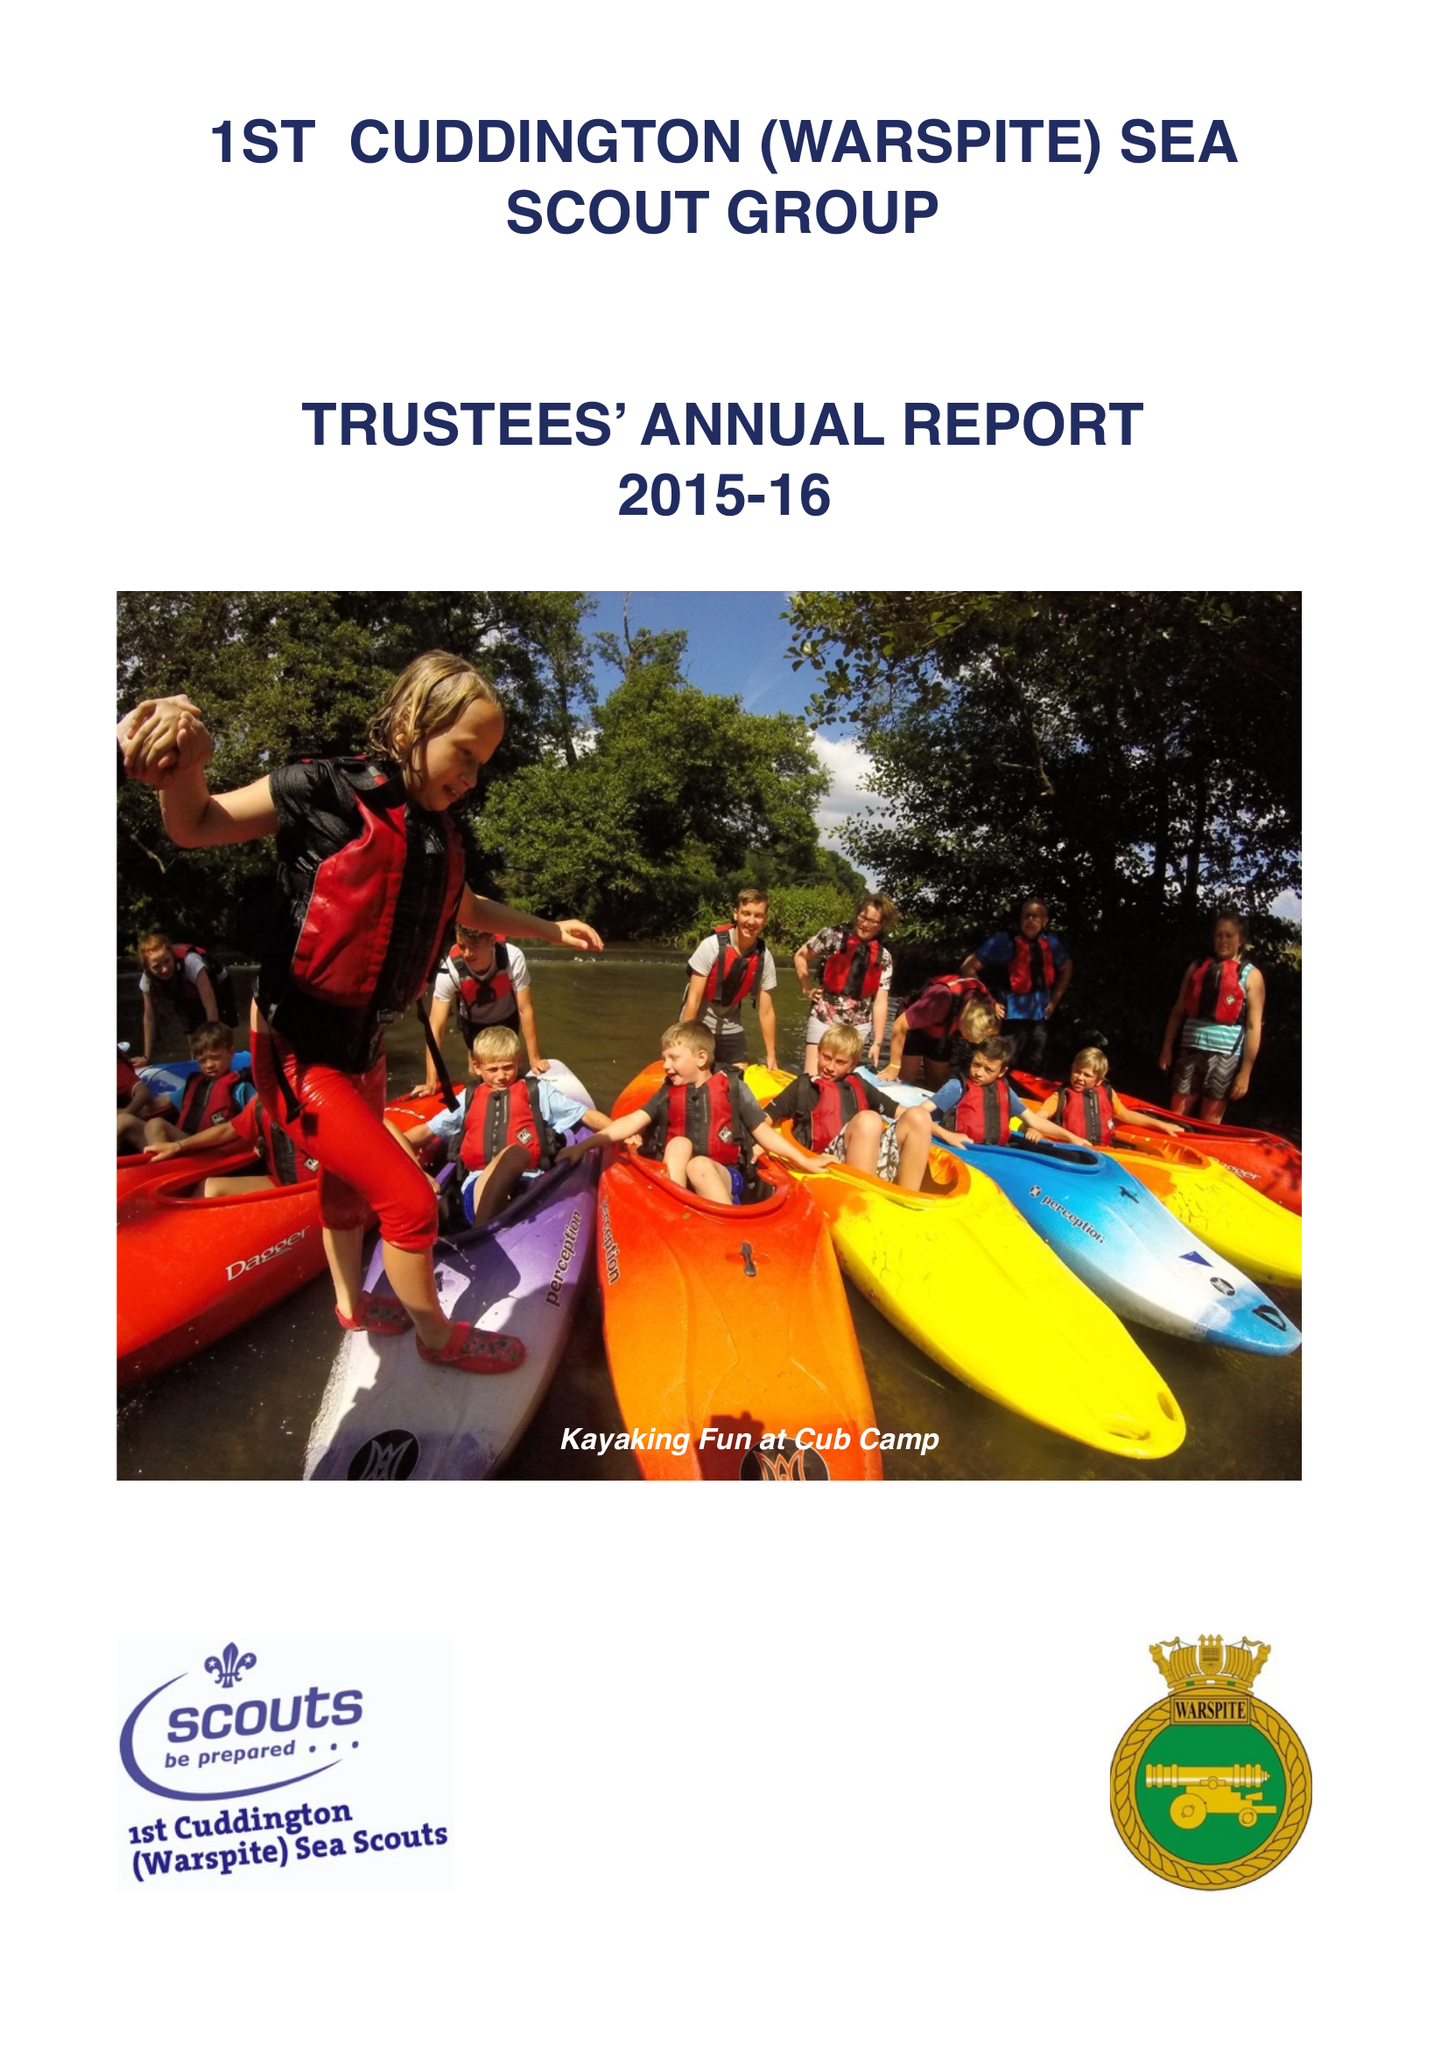What is the value for the charity_name?
Answer the question using a single word or phrase. 1st Cuddington (Warspite) Sea Scout Group 